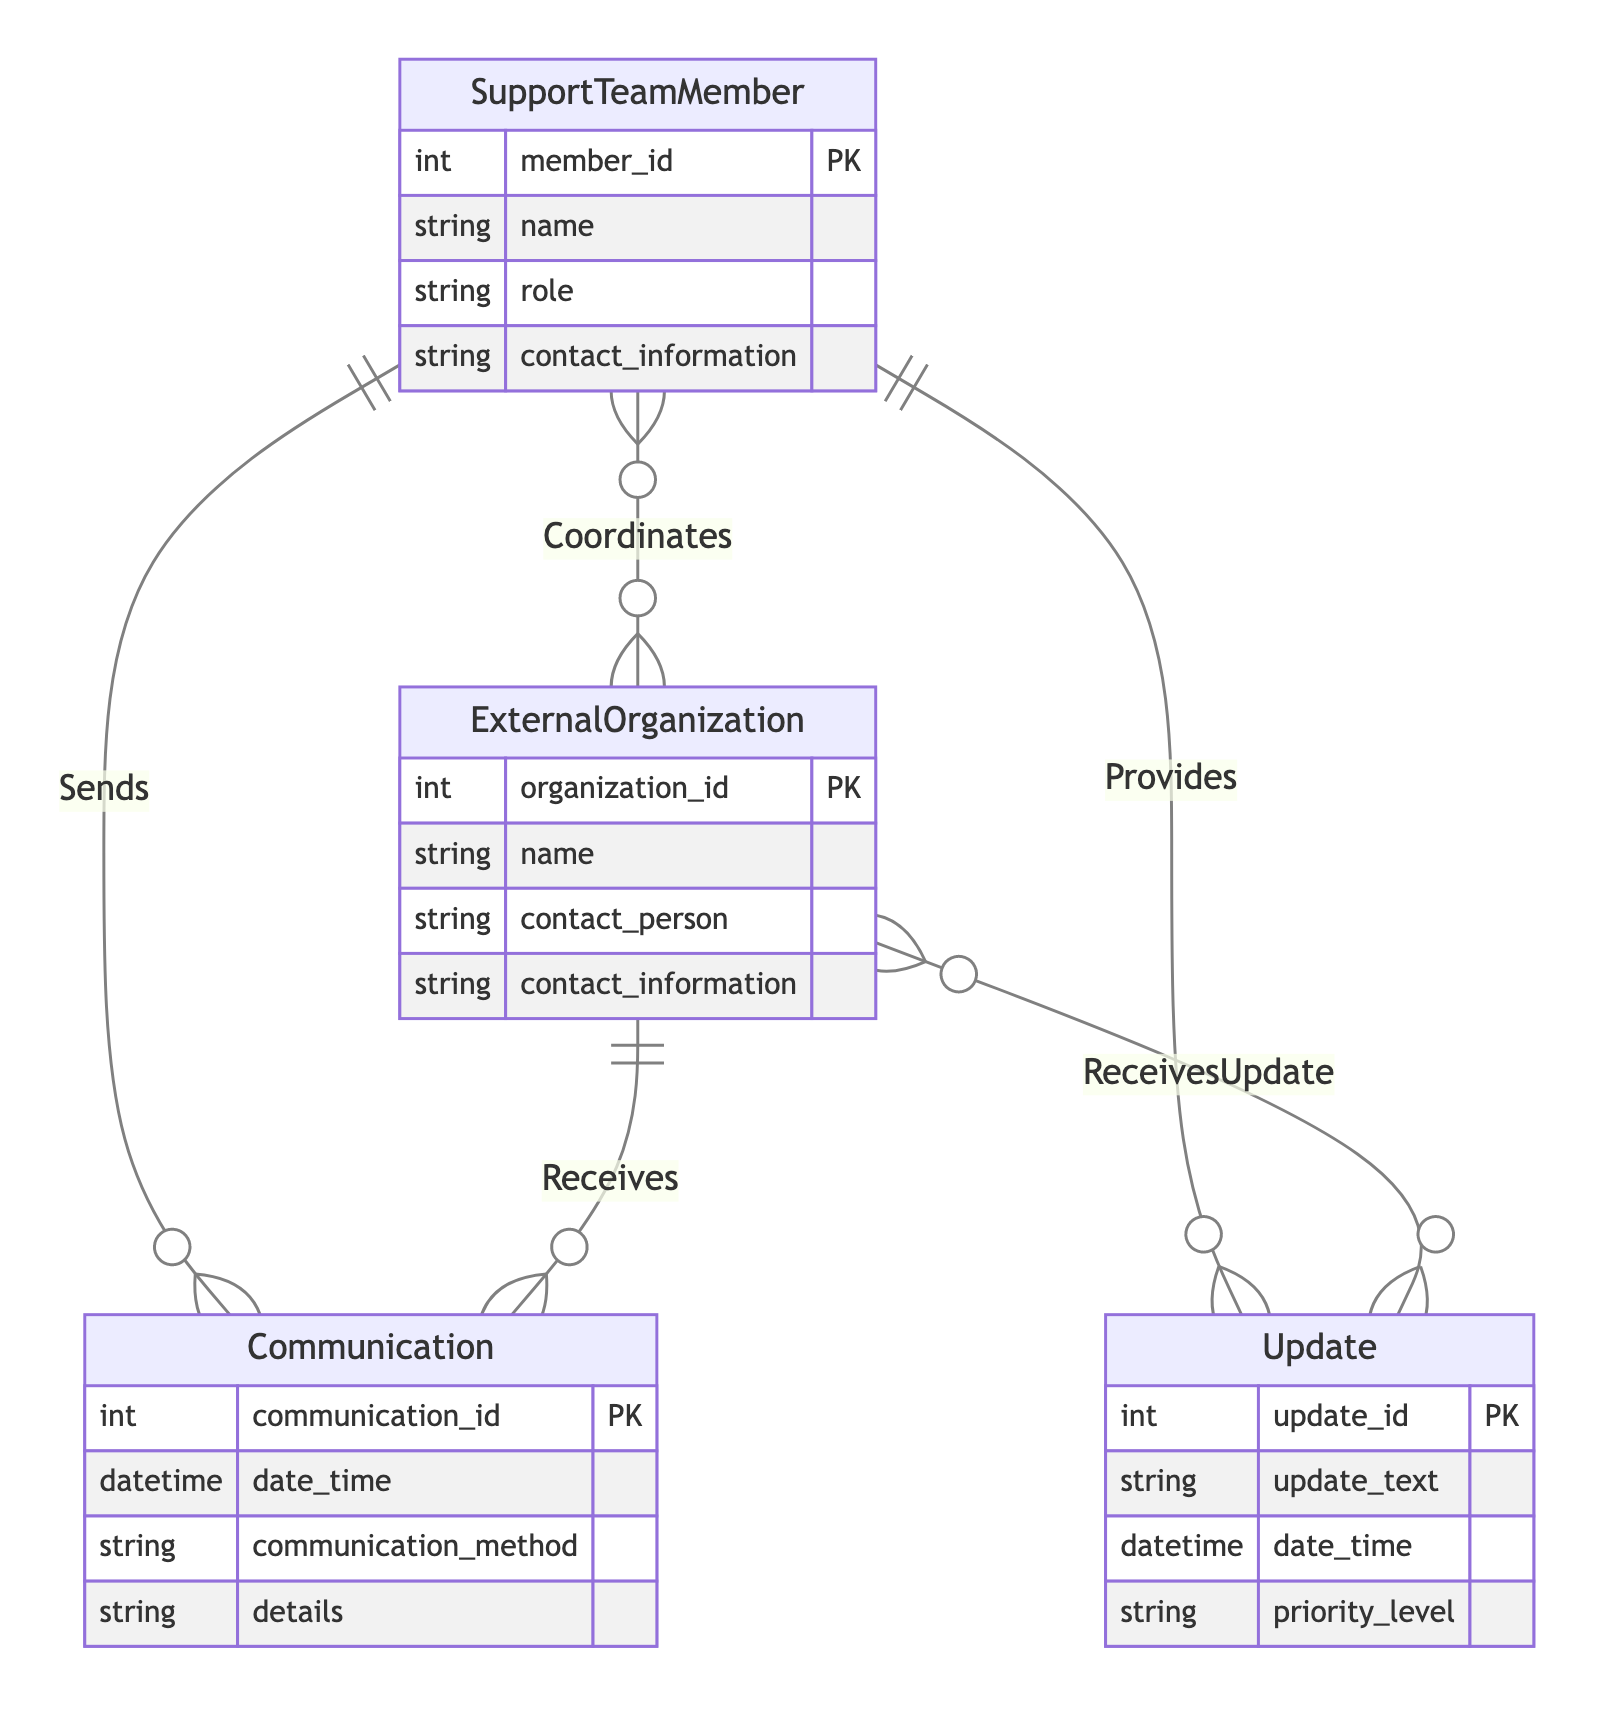What is the primary key of the SupportTeamMember entity? The primary key is noted as "PK" and is defined as "member_id" in the SupportTeamMember entity, indicating that it uniquely identifies each Support Team Member.
Answer: member_id How many different attributes does the ExternalOrganization entity have? By counting the listed attributes under ExternalOrganization, we find that there are four attributes: organization_id, name, contact_person, and contact_information.
Answer: 4 What type of relationship connects SupportTeamMember and Communication? The diagram indicates that the relationship between SupportTeamMember and Communication is labeled "Sends," and it is defined as a many-to-many relationship, meaning multiple team members can send multiple communications.
Answer: many-to-many Which entity receives communications from ExternalOrganizations? The relationship labeled "Receives" connects ExternalOrganization to the Communication entity, indicating that ExternalOrganizations receive communications.
Answer: Communication How is the relationship between SupportTeamMember and ExternalOrganization defined? The relationship is named "Coordinates," and it is classified as many-to-many, meaning that multiple Support Team Members can coordinate with multiple External Organizations.
Answer: many-to-many What is the significance of the relationship named "ReceivesUpdate"? This relationship connects ExternalOrganization to the Update entity and is defined as many-to-many, indicating that multiple External Organizations can receive multiple updates, allowing for organized information sharing.
Answer: many-to-many Which entity has a one-to-many relationship with Update? The SupportTeamMember entity exhibits a one-to-many relationship with the Update entity, indicating that a single Support Team Member can provide multiple updates.
Answer: SupportTeamMember What detail can be found in the Communication entity regarding the method used? The Communication entity has an attribute labeled "communication_method," which specifies the method used for the communication, such as email, call, etc.
Answer: communication_method Which entity represents information shared with ExternalOrganizations? The Update entity represents the information that can be sent to External Organizations, as it shows the relevant updates they receive from Support Team Members.
Answer: Update 